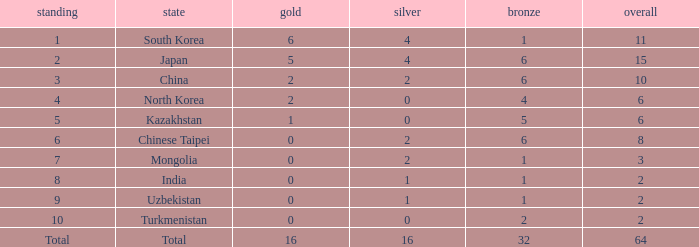What's the biggest Bronze that has less than 0 Silvers? None. 